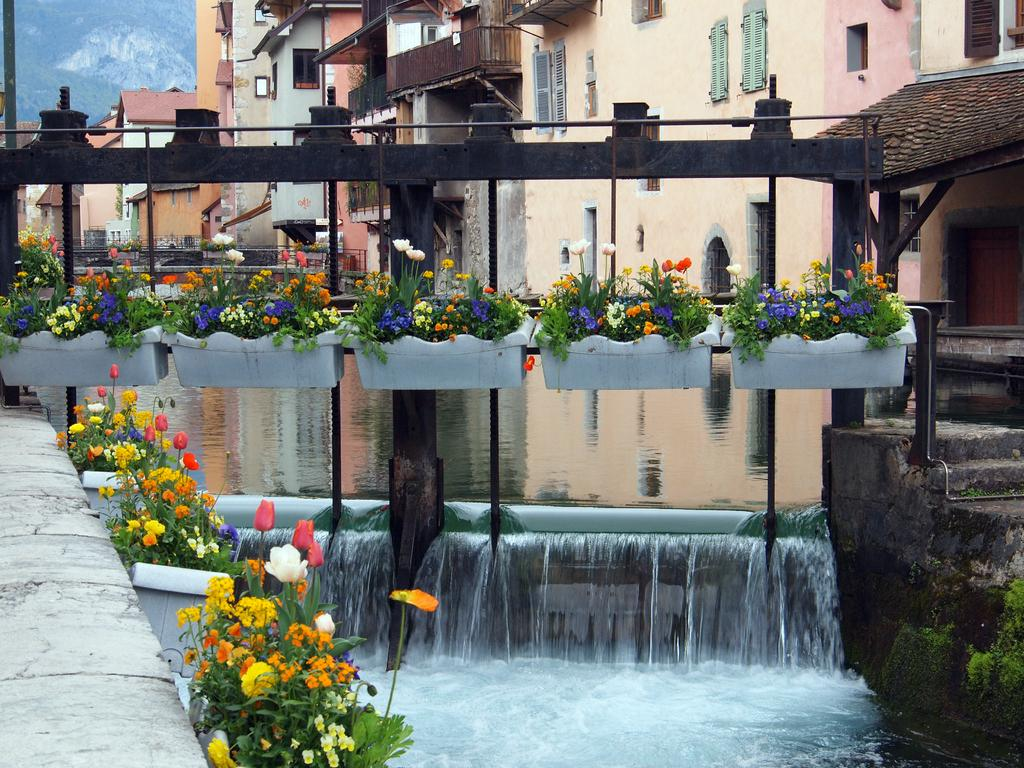What type of living organisms can be seen in the image? Plants and flowers are visible in the image. What is the primary element present in the image? Water is visible in the image. What type of man-made structures can be seen in the image? Buildings are present in the image. What natural feature is visible in the image? There is a hill in the image. How many pizzas can be seen on the hill in the image? There are no pizzas present in the image; it features plants, flowers, water, buildings, and a hill. What is the view from the top of the hill in the image? The image does not show a view from the top of the hill, as it only provides a perspective from ground level. 